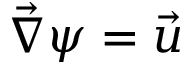Convert formula to latex. <formula><loc_0><loc_0><loc_500><loc_500>\vec { \nabla } \psi = \vec { u }</formula> 